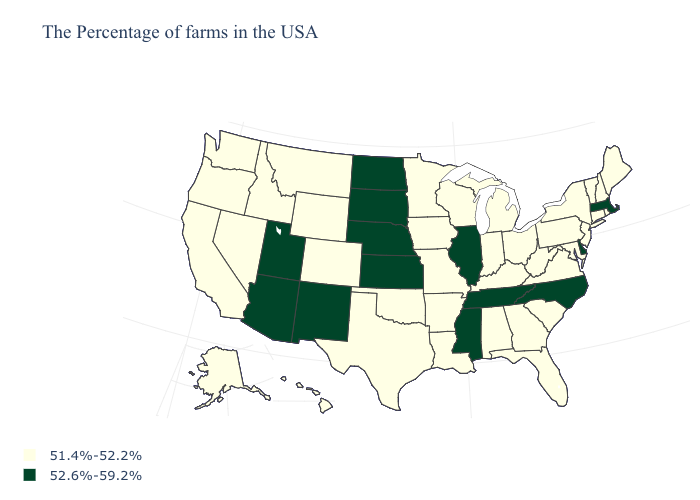Name the states that have a value in the range 51.4%-52.2%?
Short answer required. Maine, Rhode Island, New Hampshire, Vermont, Connecticut, New York, New Jersey, Maryland, Pennsylvania, Virginia, South Carolina, West Virginia, Ohio, Florida, Georgia, Michigan, Kentucky, Indiana, Alabama, Wisconsin, Louisiana, Missouri, Arkansas, Minnesota, Iowa, Oklahoma, Texas, Wyoming, Colorado, Montana, Idaho, Nevada, California, Washington, Oregon, Alaska, Hawaii. Does the first symbol in the legend represent the smallest category?
Be succinct. Yes. Does South Dakota have the lowest value in the USA?
Be succinct. No. What is the value of North Carolina?
Quick response, please. 52.6%-59.2%. Is the legend a continuous bar?
Be succinct. No. What is the value of Massachusetts?
Keep it brief. 52.6%-59.2%. Name the states that have a value in the range 52.6%-59.2%?
Short answer required. Massachusetts, Delaware, North Carolina, Tennessee, Illinois, Mississippi, Kansas, Nebraska, South Dakota, North Dakota, New Mexico, Utah, Arizona. Is the legend a continuous bar?
Quick response, please. No. Name the states that have a value in the range 51.4%-52.2%?
Short answer required. Maine, Rhode Island, New Hampshire, Vermont, Connecticut, New York, New Jersey, Maryland, Pennsylvania, Virginia, South Carolina, West Virginia, Ohio, Florida, Georgia, Michigan, Kentucky, Indiana, Alabama, Wisconsin, Louisiana, Missouri, Arkansas, Minnesota, Iowa, Oklahoma, Texas, Wyoming, Colorado, Montana, Idaho, Nevada, California, Washington, Oregon, Alaska, Hawaii. What is the value of Maine?
Write a very short answer. 51.4%-52.2%. Name the states that have a value in the range 51.4%-52.2%?
Give a very brief answer. Maine, Rhode Island, New Hampshire, Vermont, Connecticut, New York, New Jersey, Maryland, Pennsylvania, Virginia, South Carolina, West Virginia, Ohio, Florida, Georgia, Michigan, Kentucky, Indiana, Alabama, Wisconsin, Louisiana, Missouri, Arkansas, Minnesota, Iowa, Oklahoma, Texas, Wyoming, Colorado, Montana, Idaho, Nevada, California, Washington, Oregon, Alaska, Hawaii. What is the value of Mississippi?
Quick response, please. 52.6%-59.2%. What is the value of Pennsylvania?
Write a very short answer. 51.4%-52.2%. Among the states that border Wisconsin , which have the lowest value?
Quick response, please. Michigan, Minnesota, Iowa. Name the states that have a value in the range 52.6%-59.2%?
Answer briefly. Massachusetts, Delaware, North Carolina, Tennessee, Illinois, Mississippi, Kansas, Nebraska, South Dakota, North Dakota, New Mexico, Utah, Arizona. 